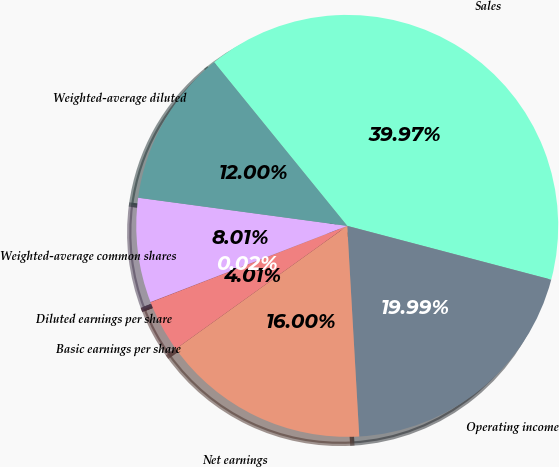Convert chart to OTSL. <chart><loc_0><loc_0><loc_500><loc_500><pie_chart><fcel>Sales<fcel>Operating income<fcel>Net earnings<fcel>Basic earnings per share<fcel>Diluted earnings per share<fcel>Weighted-average common shares<fcel>Weighted-average diluted<nl><fcel>39.97%<fcel>19.99%<fcel>16.0%<fcel>4.01%<fcel>0.02%<fcel>8.01%<fcel>12.0%<nl></chart> 